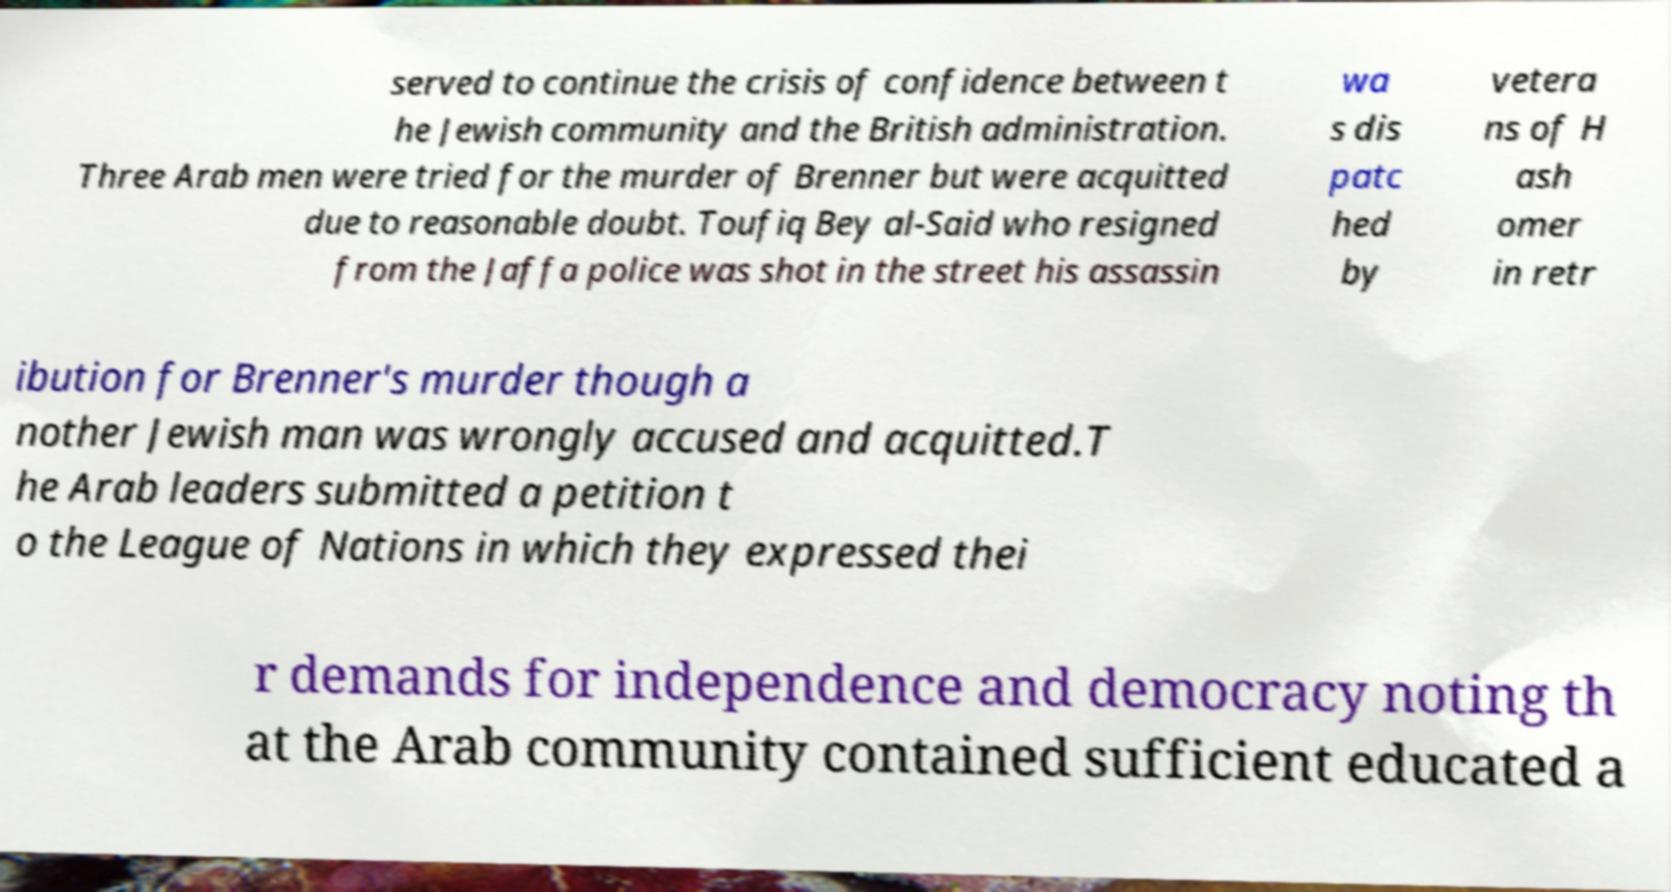I need the written content from this picture converted into text. Can you do that? served to continue the crisis of confidence between t he Jewish community and the British administration. Three Arab men were tried for the murder of Brenner but were acquitted due to reasonable doubt. Toufiq Bey al-Said who resigned from the Jaffa police was shot in the street his assassin wa s dis patc hed by vetera ns of H ash omer in retr ibution for Brenner's murder though a nother Jewish man was wrongly accused and acquitted.T he Arab leaders submitted a petition t o the League of Nations in which they expressed thei r demands for independence and democracy noting th at the Arab community contained sufficient educated a 